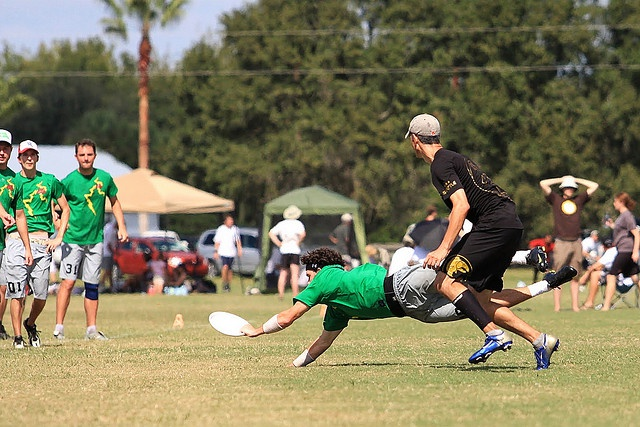Describe the objects in this image and their specific colors. I can see people in lavender, black, maroon, tan, and ivory tones, people in lavender, black, white, lightgreen, and gray tones, people in lavender, green, lightgray, salmon, and darkgreen tones, people in lavender, lightgray, black, darkgray, and tan tones, and people in lavender, maroon, tan, and beige tones in this image. 